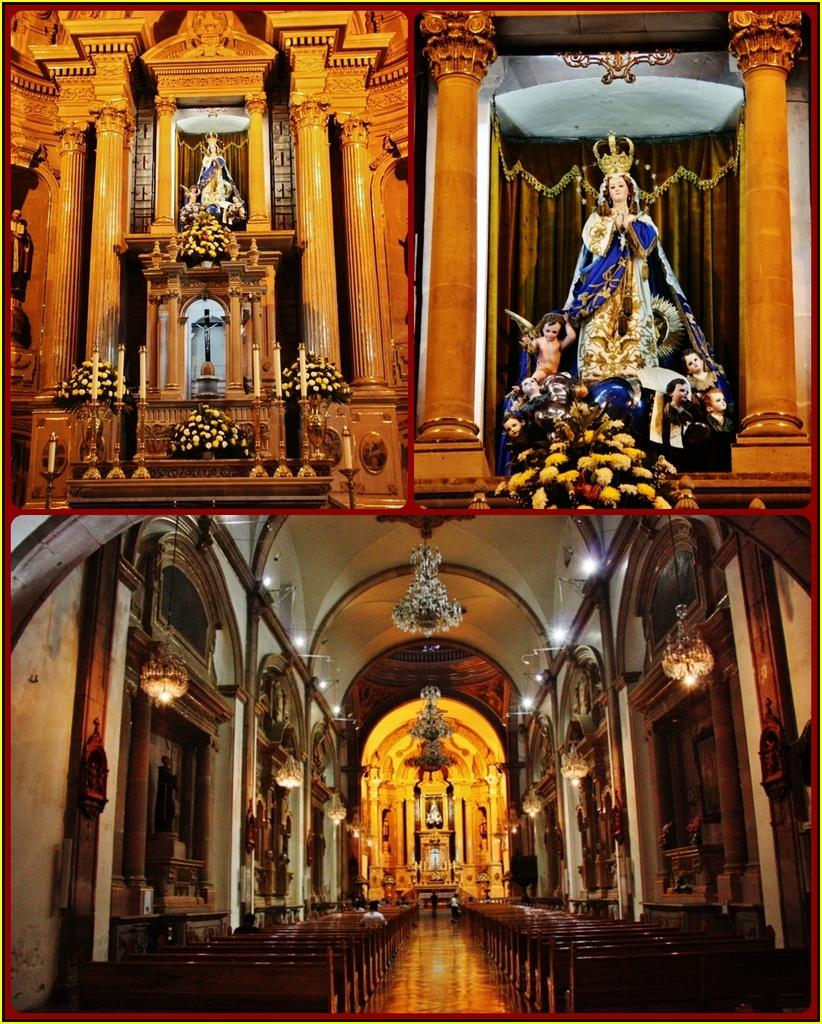What is the main subject of the image? The main subject of the image is a collage of images of a church. What type of seating is visible in the image? There are benches in the image. What kind of lighting is present in the image? There are lights and hanging lights in the image. What architectural features can be seen in the image? There are pillars in the image. What decorative items are present in the image? There are bouquets and sculptures in the image. What type of background is visible in the image? There is a wall visible in the image. What time of day is being discussed in the image? There is no discussion of time in the image; it is a collage of images of a church with various elements and objects. What type of discovery is being made in the image? There is no discovery being made in the image; it is a collage of images of a church with various elements and objects. 